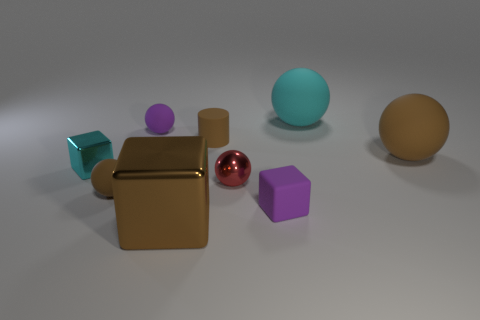There is a block that is the same color as the tiny cylinder; what material is it?
Ensure brevity in your answer.  Metal. Do the cyan block and the red metal ball have the same size?
Your answer should be compact. Yes. What number of objects are small gray shiny balls or small rubber things left of the shiny ball?
Offer a very short reply. 3. What material is the purple sphere that is the same size as the brown cylinder?
Make the answer very short. Rubber. What is the ball that is both left of the cyan rubber thing and to the right of the purple ball made of?
Provide a short and direct response. Metal. There is a big thing that is in front of the big brown matte ball; are there any matte things to the right of it?
Provide a short and direct response. Yes. There is a matte ball that is in front of the small purple ball and right of the big shiny object; what is its size?
Your response must be concise. Large. How many purple things are either tiny metal spheres or matte things?
Your answer should be compact. 2. There is a purple rubber object that is the same size as the purple rubber block; what shape is it?
Ensure brevity in your answer.  Sphere. How many other things are there of the same color as the matte cylinder?
Make the answer very short. 3. 